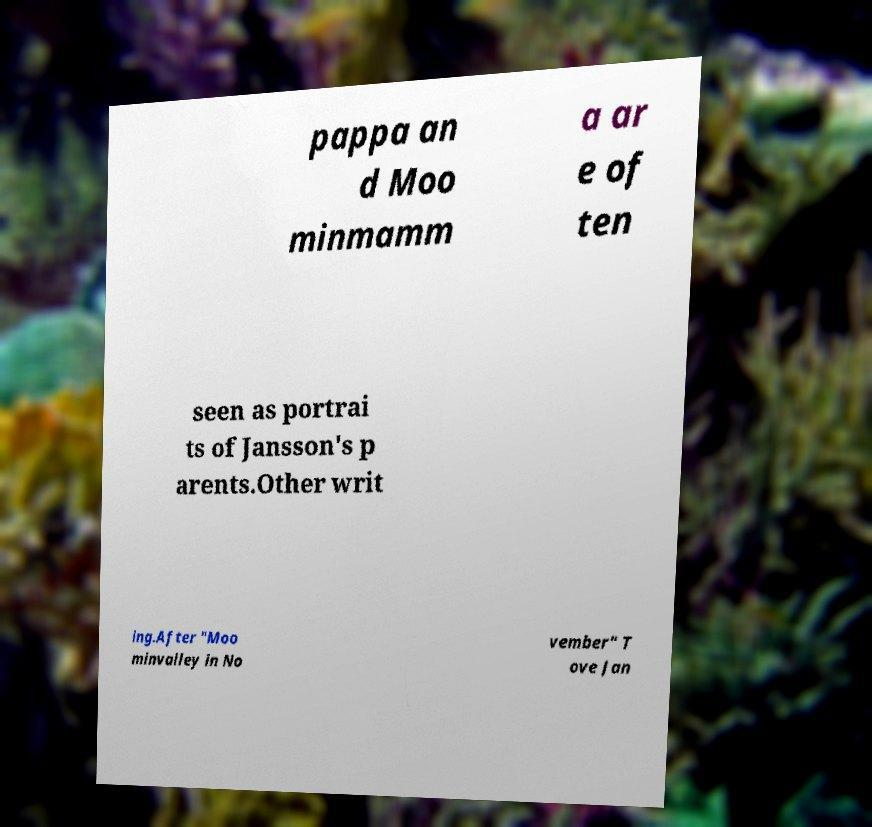I need the written content from this picture converted into text. Can you do that? pappa an d Moo minmamm a ar e of ten seen as portrai ts of Jansson's p arents.Other writ ing.After "Moo minvalley in No vember" T ove Jan 